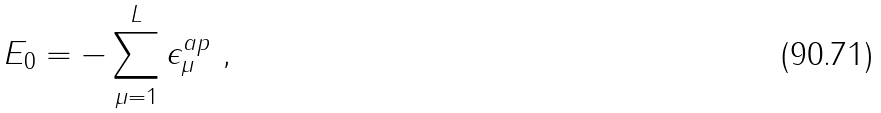Convert formula to latex. <formula><loc_0><loc_0><loc_500><loc_500>E _ { 0 } = - \sum _ { \mu = 1 } ^ { L } \epsilon _ { \mu } ^ { a p } \ ,</formula> 